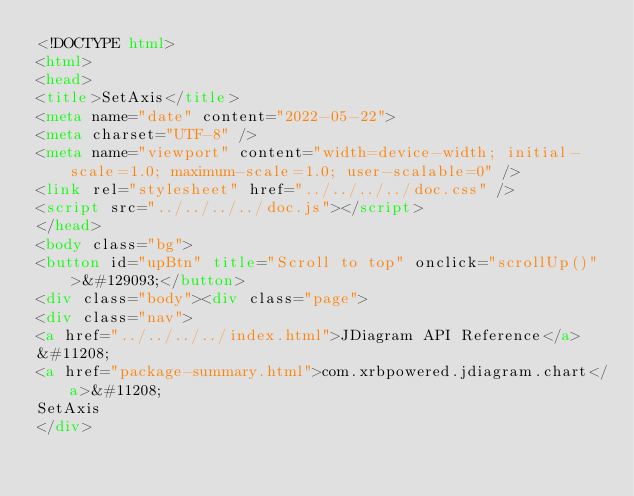<code> <loc_0><loc_0><loc_500><loc_500><_HTML_><!DOCTYPE html>
<html>
<head>
<title>SetAxis</title>
<meta name="date" content="2022-05-22">
<meta charset="UTF-8" />
<meta name="viewport" content="width=device-width; initial-scale=1.0; maximum-scale=1.0; user-scalable=0" />
<link rel="stylesheet" href="../../../../doc.css" />
<script src="../../../../doc.js"></script>
</head>
<body class="bg">
<button id="upBtn" title="Scroll to top" onclick="scrollUp()">&#129093;</button>
<div class="body"><div class="page">
<div class="nav">
<a href="../../../../index.html">JDiagram API Reference</a>
&#11208; 
<a href="package-summary.html">com.xrbpowered.jdiagram.chart</a>&#11208; 
SetAxis
</div></code> 